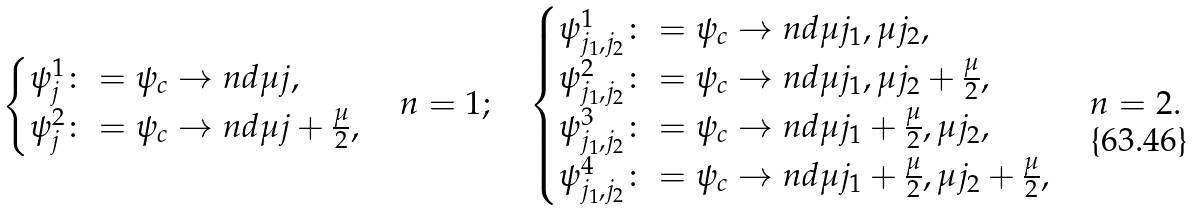Convert formula to latex. <formula><loc_0><loc_0><loc_500><loc_500>\begin{cases} \psi ^ { 1 } _ { j } \colon = \psi _ { c } \to n d { \mu j } , \\ \psi ^ { 2 } _ { j } \colon = \psi _ { c } \to n d { \mu j + \frac { \mu } { 2 } } , \end{cases} n = 1 ; \quad \begin{cases} \psi ^ { 1 } _ { j _ { 1 } , j _ { 2 } } \colon = \psi _ { c } \to n d { \mu j _ { 1 } , \mu j _ { 2 } } , \\ \psi ^ { 2 } _ { j _ { 1 } , j _ { 2 } } \colon = \psi _ { c } \to n d { \mu j _ { 1 } , \mu j _ { 2 } + \frac { \mu } { 2 } } , \\ \psi ^ { 3 } _ { j _ { 1 } , j _ { 2 } } \colon = \psi _ { c } \to n d { \mu j _ { 1 } + \frac { \mu } { 2 } , \mu j _ { 2 } } , \\ \psi ^ { 4 } _ { j _ { 1 } , j _ { 2 } } \colon = \psi _ { c } \to n d { \mu j _ { 1 } + \frac { \mu } { 2 } , \mu j _ { 2 } + \frac { \mu } { 2 } } , \end{cases} n = 2 .</formula> 